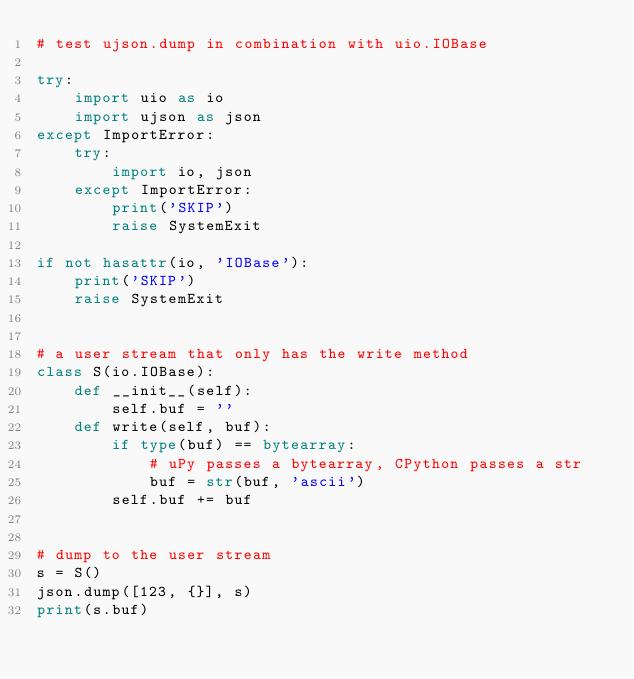Convert code to text. <code><loc_0><loc_0><loc_500><loc_500><_Python_># test ujson.dump in combination with uio.IOBase

try:
    import uio as io
    import ujson as json
except ImportError:
    try:
        import io, json
    except ImportError:
        print('SKIP')
        raise SystemExit

if not hasattr(io, 'IOBase'):
    print('SKIP')
    raise SystemExit


# a user stream that only has the write method
class S(io.IOBase):
    def __init__(self):
        self.buf = ''
    def write(self, buf):
        if type(buf) == bytearray:
            # uPy passes a bytearray, CPython passes a str
            buf = str(buf, 'ascii')
        self.buf += buf


# dump to the user stream
s = S()
json.dump([123, {}], s)
print(s.buf)
</code> 